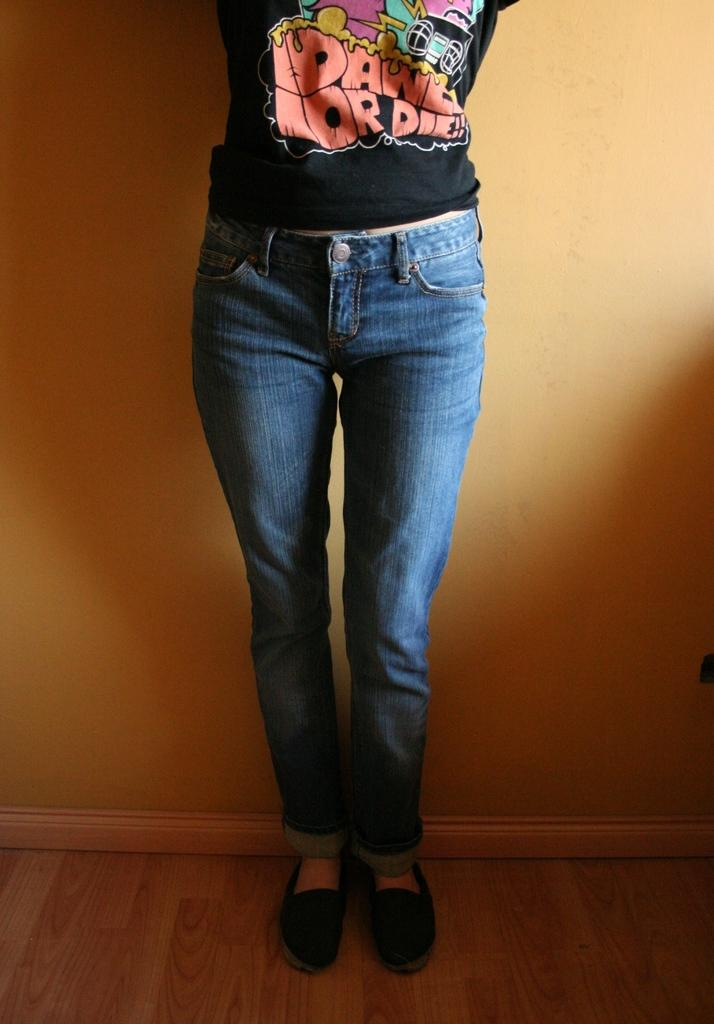What type of figure can be seen in the image? There is a human in the image. What can be seen in the background of the image? There is a wall in the background of the image. What type of support does the human provide in the image? There is no indication in the image of the human providing any support. Can you tell me the name of the judge in the image? There is no judge present in the image, only a human figure. 